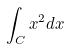<formula> <loc_0><loc_0><loc_500><loc_500>\int _ { C } x ^ { 2 } d x</formula> 